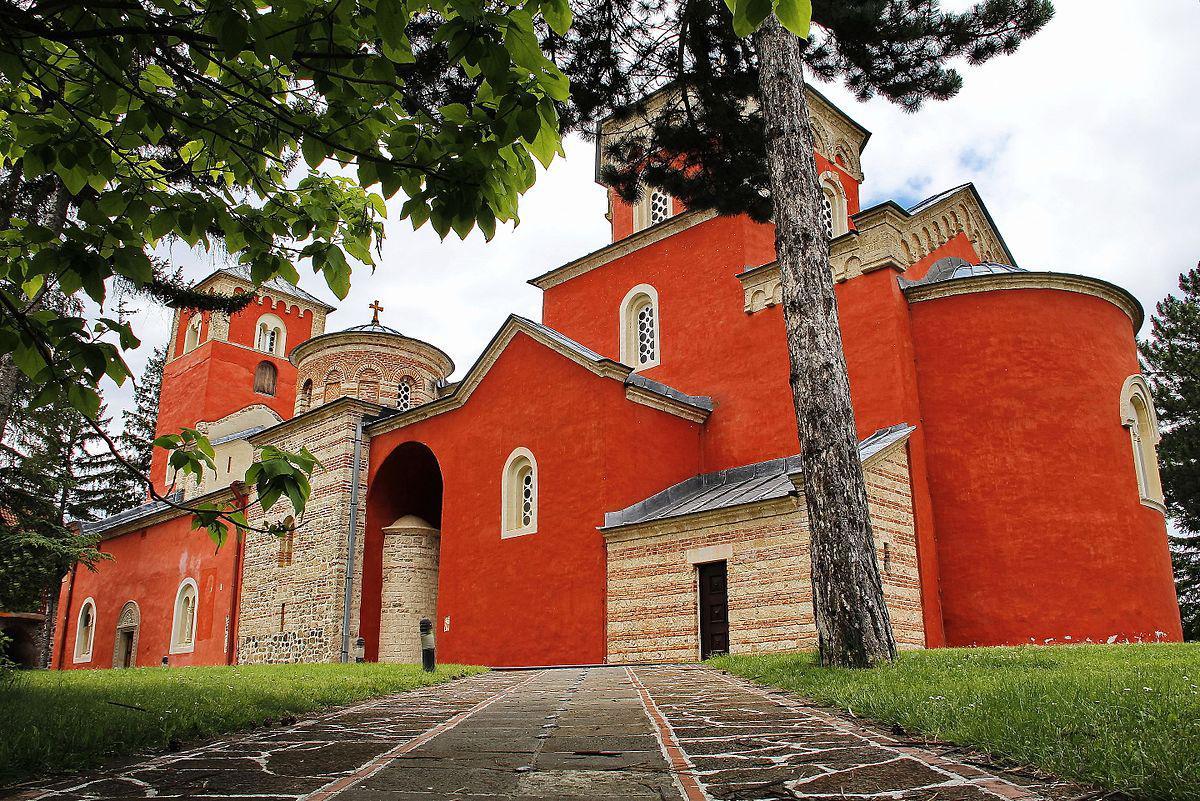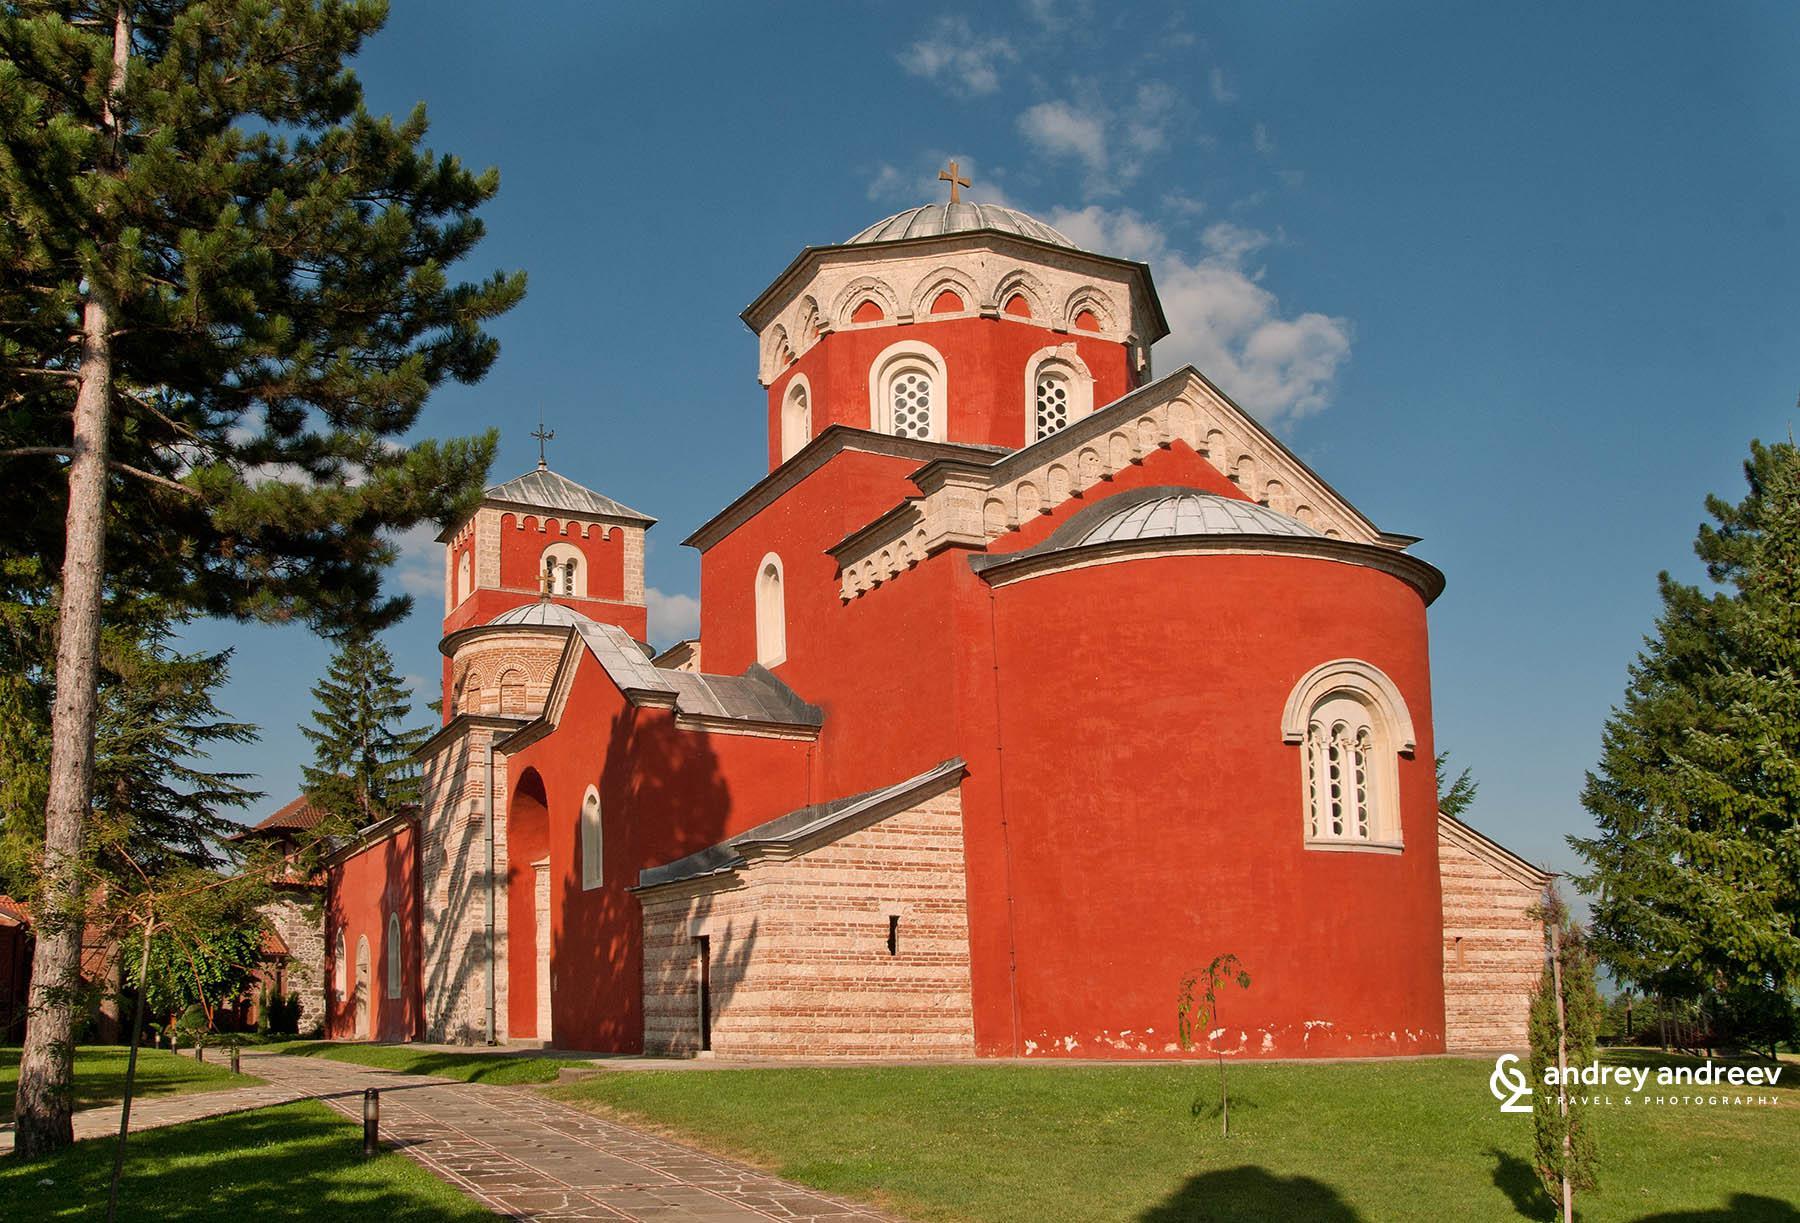The first image is the image on the left, the second image is the image on the right. Analyze the images presented: Is the assertion "An ornate orange monastery has a rounded structure at one end with one central window with a curved top, and a small shed-like structure on at least one side." valid? Answer yes or no. Yes. The first image is the image on the left, the second image is the image on the right. Examine the images to the left and right. Is the description "Each image shows a red-orange building featuring a dome structure topped with a cross." accurate? Answer yes or no. Yes. 